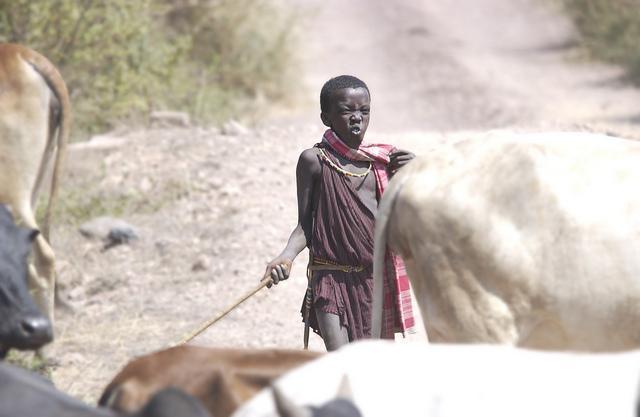How many cows are there?
Give a very brief answer. 5. 